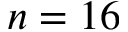Convert formula to latex. <formula><loc_0><loc_0><loc_500><loc_500>n = 1 6</formula> 